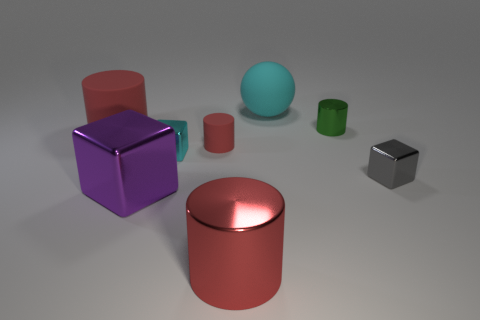Are there any indications about the setting or location where these objects are placed? The objects are arranged on a flat, neutral-toned surface with a subtle gradient, giving the impression of a controlled, studio-like environment typically used for product design visualization or material studies. Can you speculate about the function or purpose of these objects, if any? From the image, it appears these objects serve as geometric shapes primarily for visual or educational purposes, such as demonstrating the qualities of different materials or for use in a graphical interface as illustrative elements. 